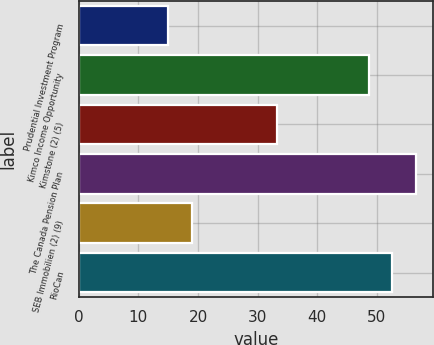Convert chart to OTSL. <chart><loc_0><loc_0><loc_500><loc_500><bar_chart><fcel>Prudential Investment Program<fcel>Kimco Income Opportunity<fcel>Kimstone (2) (5)<fcel>The Canada Pension Plan<fcel>SEB Immobilien (2) (9)<fcel>RioCan<nl><fcel>15<fcel>48.6<fcel>33.3<fcel>56.6<fcel>19<fcel>52.6<nl></chart> 